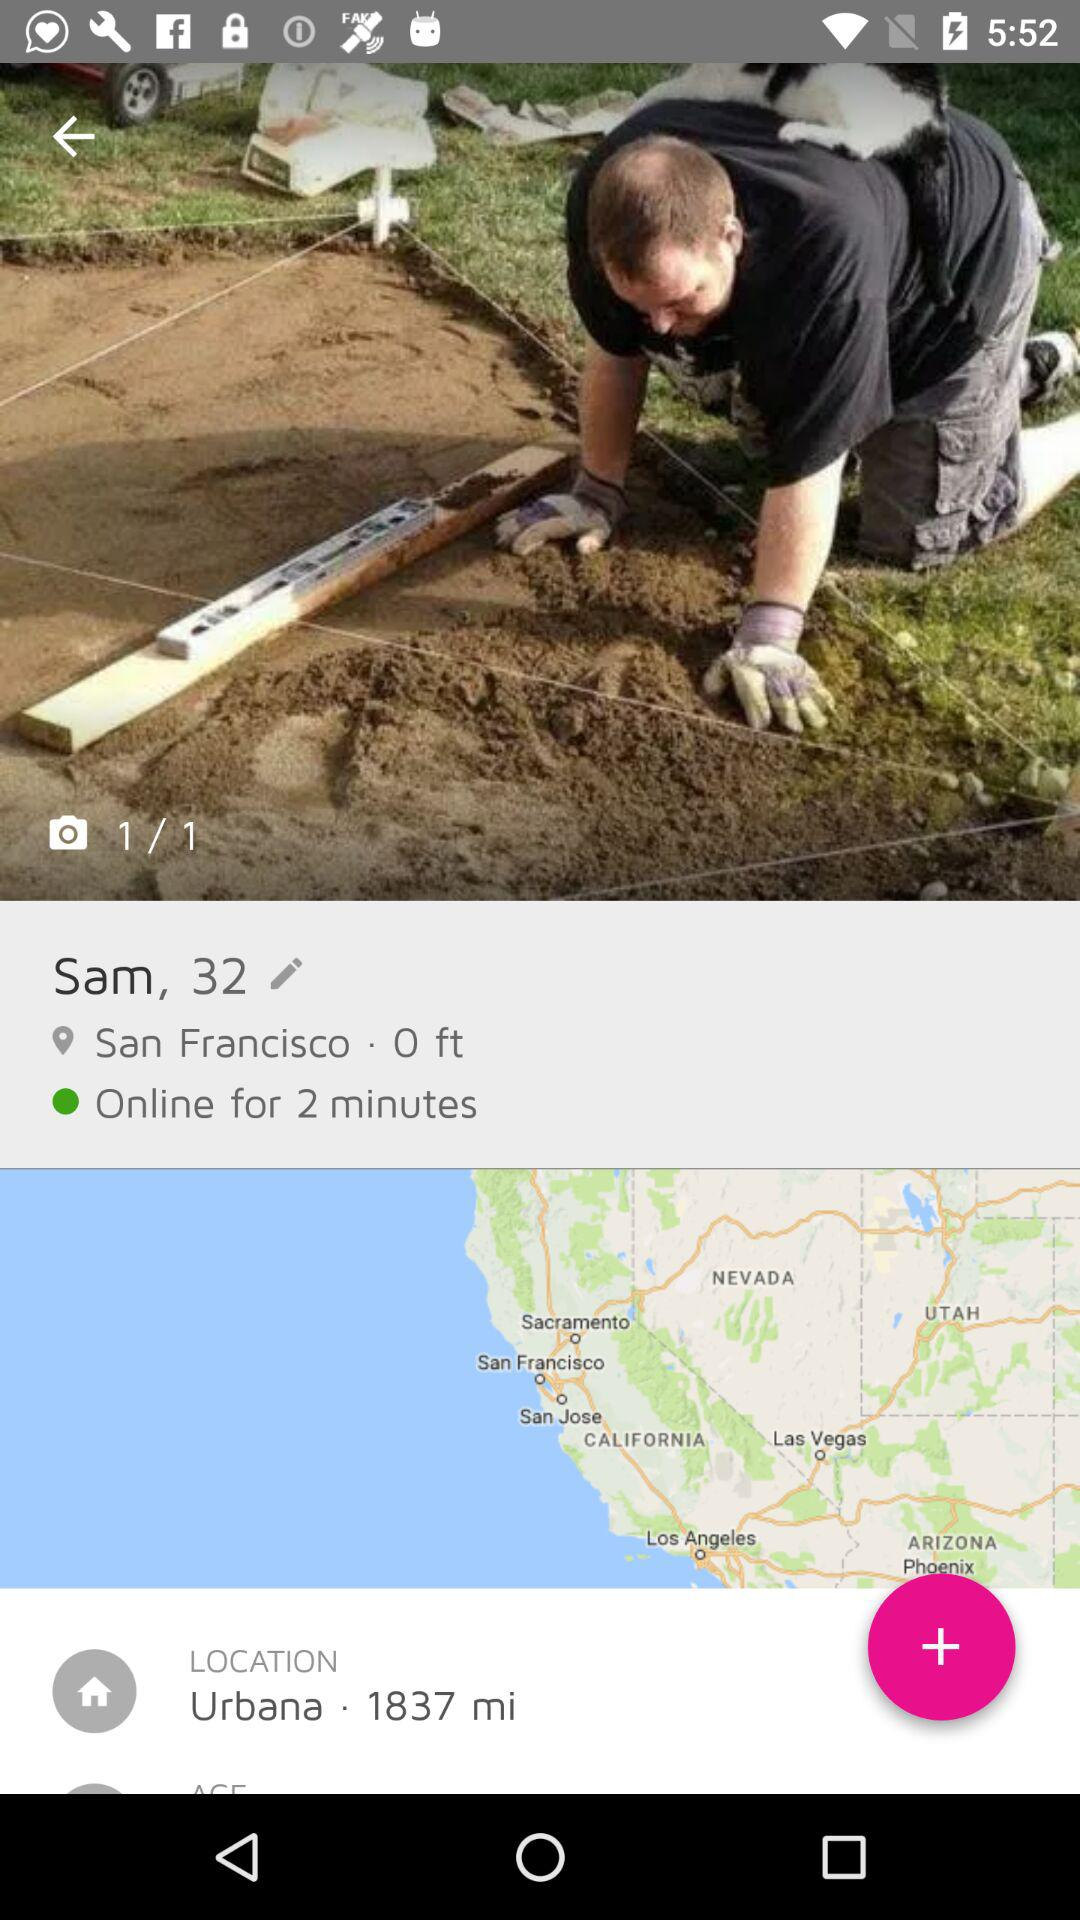How many minutes has the user been online?
Answer the question using a single word or phrase. 2 